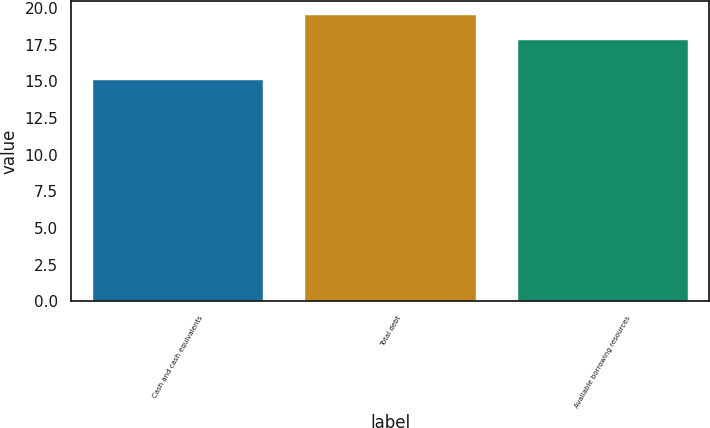Convert chart. <chart><loc_0><loc_0><loc_500><loc_500><bar_chart><fcel>Cash and cash equivalents<fcel>Total debt<fcel>Available borrowing resources<nl><fcel>15.1<fcel>19.5<fcel>17.8<nl></chart> 